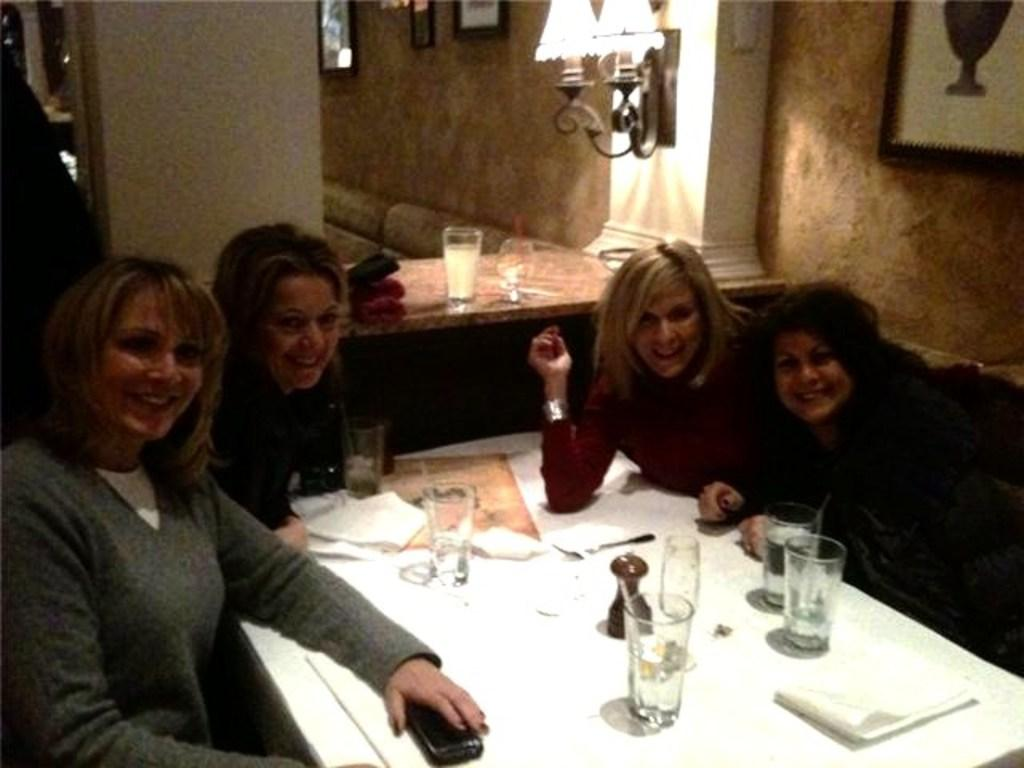What are the people in the image doing? The people in the image are sitting on chairs. What is present in the image besides the people? There is a table in the image. What objects can be seen on the table? There are glasses on the table in the image. How many potatoes are visible on the table in the image? There are no potatoes present on the table in the image. 